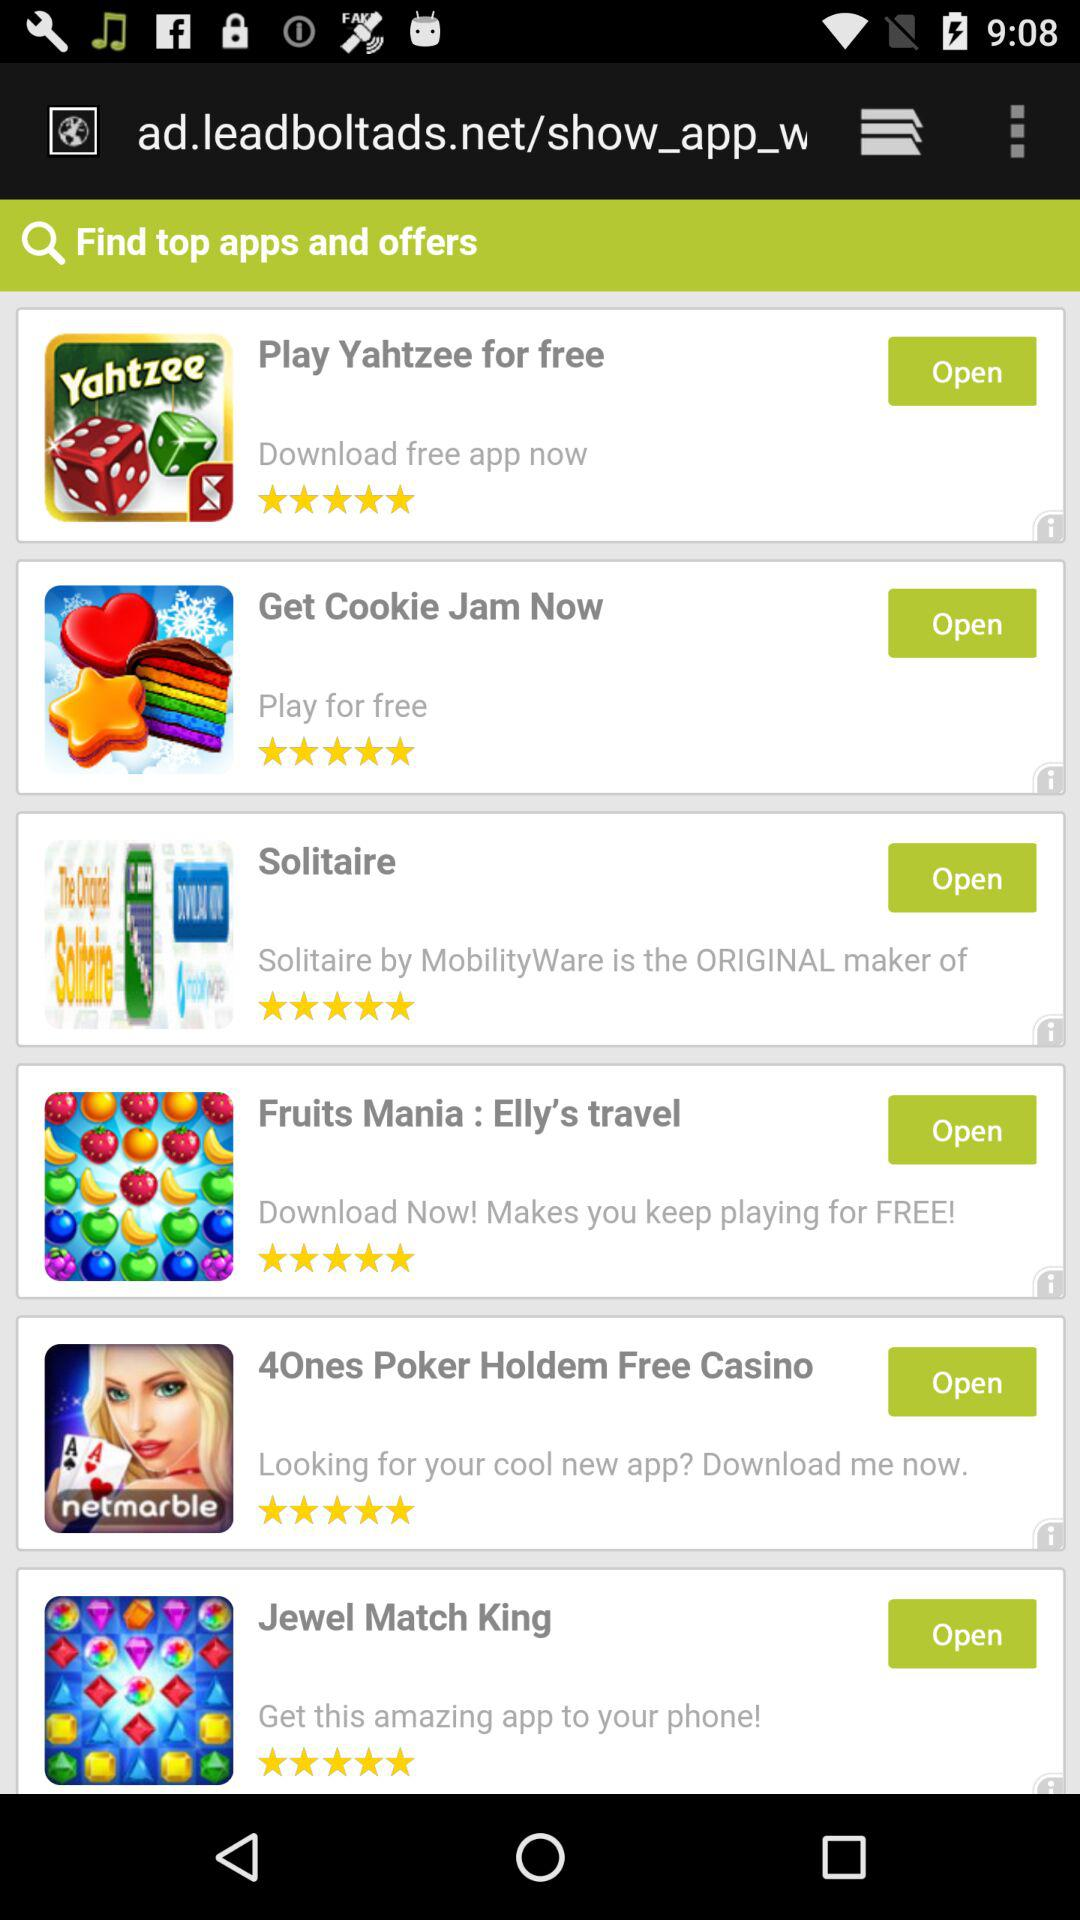How many stars are given to "Solitaire"? The stars given to "Solitaire" are 5. 